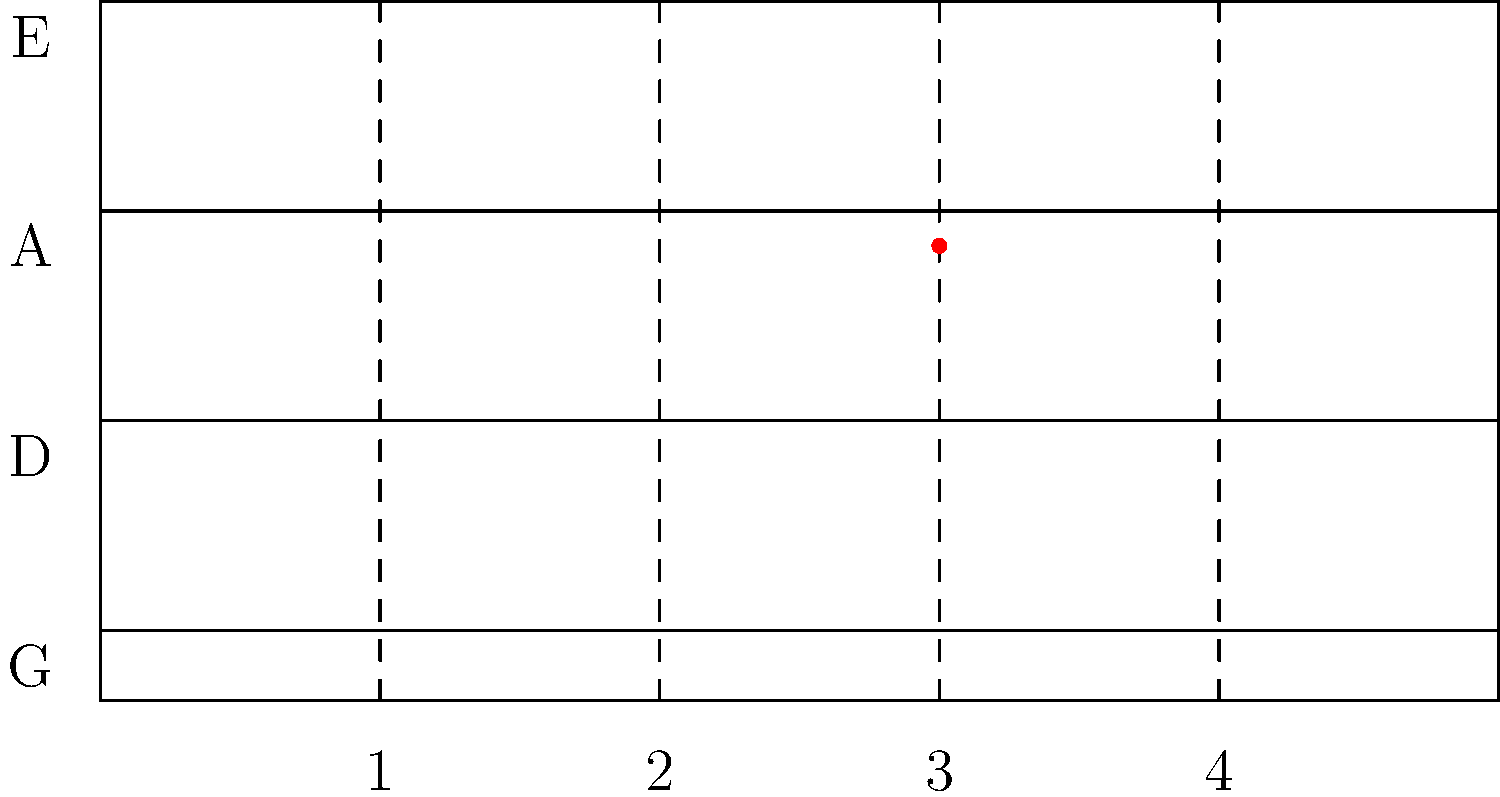On the violin fingerboard diagram, which finger position and string combination is highlighted for playing the note C#? To determine the correct finger position and string for C#, let's follow these steps:

1. Identify the strings: From top to bottom, the strings are E, A, D, and G.

2. Locate the highlighted position: The red dot is on the second string from the top (A string) and at the third finger position.

3. Understand finger positions: On a violin, the first finger plays a whole step above the open string, the second finger plays a half step after the first, the third finger plays a whole step after the second, and the fourth finger plays a half step after the third.

4. Analyze the A string: 
   - Open A
   - 1st finger: B
   - 2nd finger: C
   - 3rd finger: C# (highlighted position)
   - 4th finger: D

5. Confirm the note: The highlighted position (3rd finger on the A string) indeed produces C#.

Therefore, the correct fingering for C# is the 3rd finger on the A string.
Answer: 3rd finger, A string 